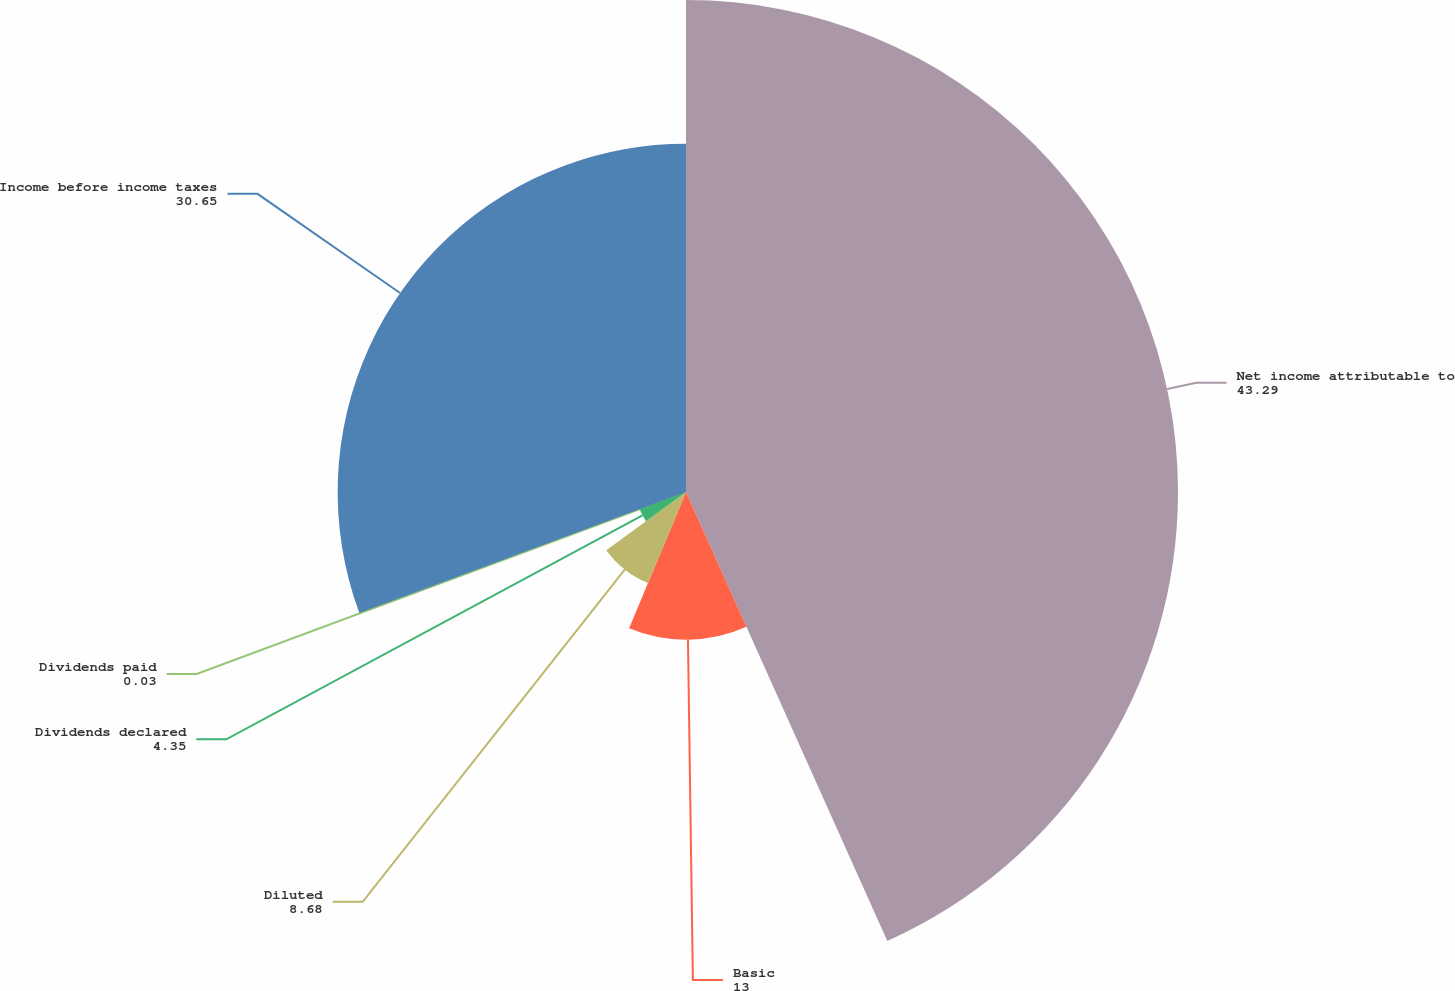Convert chart to OTSL. <chart><loc_0><loc_0><loc_500><loc_500><pie_chart><fcel>Net income attributable to<fcel>Basic<fcel>Diluted<fcel>Dividends declared<fcel>Dividends paid<fcel>Income before income taxes<nl><fcel>43.29%<fcel>13.0%<fcel>8.68%<fcel>4.35%<fcel>0.03%<fcel>30.65%<nl></chart> 